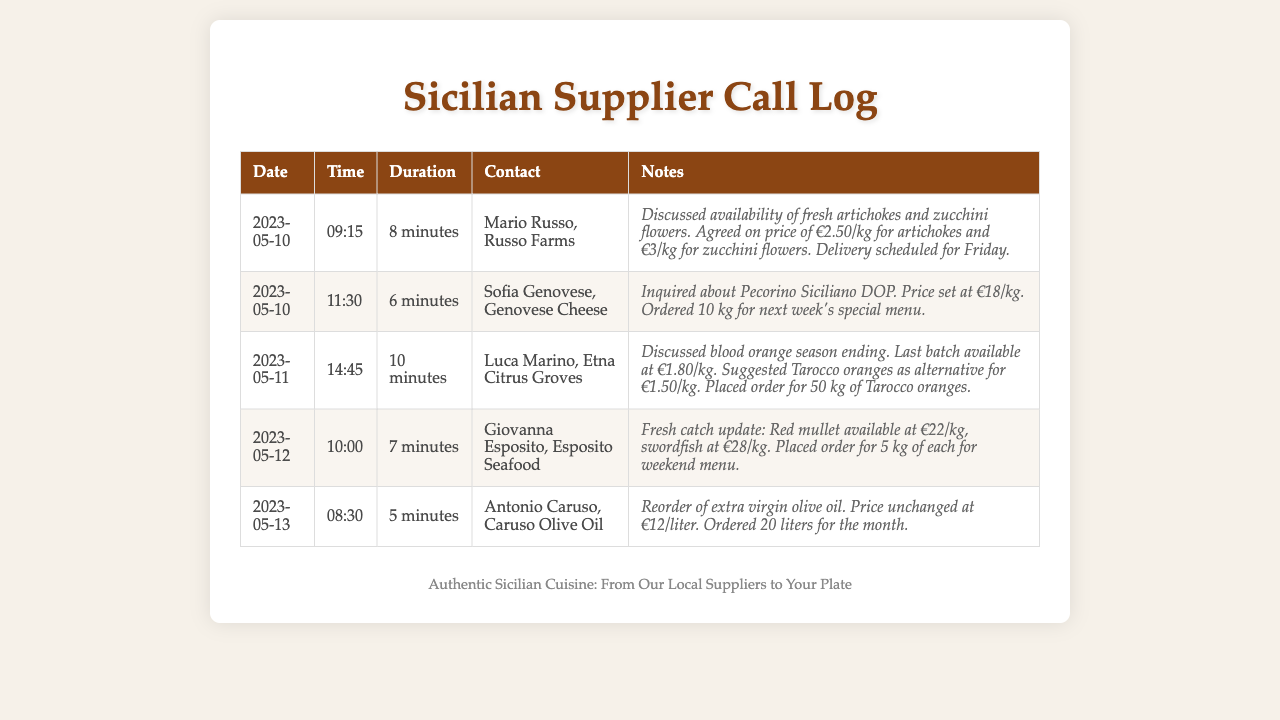What was discussed in the call with Mario Russo? The call with Mario Russo included a discussion about the availability of fresh artichokes and zucchini flowers, along with pricing.
Answer: availability of fresh artichokes and zucchini flowers What is the price for Pecorino Siciliano DOP? The document states that the price for Pecorino Siciliano DOP is €18/kg.
Answer: €18/kg When is the delivery scheduled for the artichokes? The delivery for the artichokes is scheduled for Friday, as noted in the call log.
Answer: Friday How many liters of extra virgin olive oil were ordered? The order for extra virgin olive oil was for 20 liters as mentioned in the conversation with Antonio Caruso.
Answer: 20 liters What was the last available batch of blood oranges priced at? The last batch of blood oranges was available at €1.80/kg, according to the call with Luca Marino.
Answer: €1.80/kg What seafood was ordered from Giovanna Esposito? The seafood ordered included red mullet and swordfish, as detailed in the call log.
Answer: red mullet and swordfish Where did the fresh catch updates come from? The fresh catch updates were provided by Giovanna Esposito from Esposito Seafood.
Answer: Esposito Seafood How long was the call with Sofia Genovese? The call with Sofia Genovese lasted for 6 minutes, as recorded in the log.
Answer: 6 minutes What alternative oranges were suggested by Luca Marino? The suggested alternative oranges were Tarocco oranges, noted during the call.
Answer: Tarocco oranges 